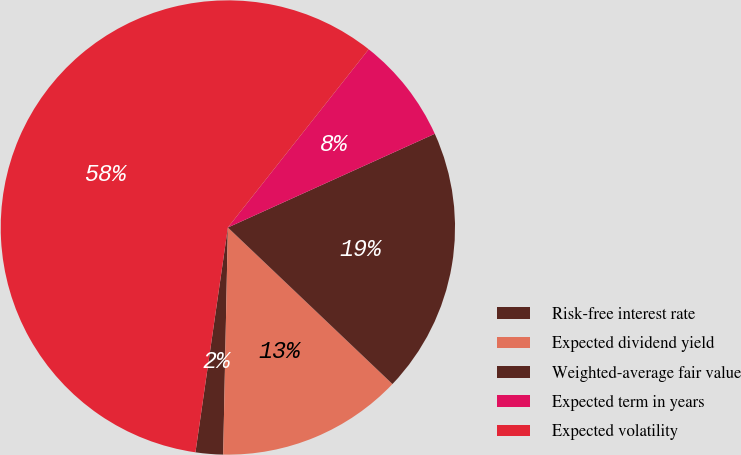<chart> <loc_0><loc_0><loc_500><loc_500><pie_chart><fcel>Risk-free interest rate<fcel>Expected dividend yield<fcel>Weighted-average fair value<fcel>Expected term in years<fcel>Expected volatility<nl><fcel>1.95%<fcel>13.23%<fcel>18.87%<fcel>7.59%<fcel>58.37%<nl></chart> 